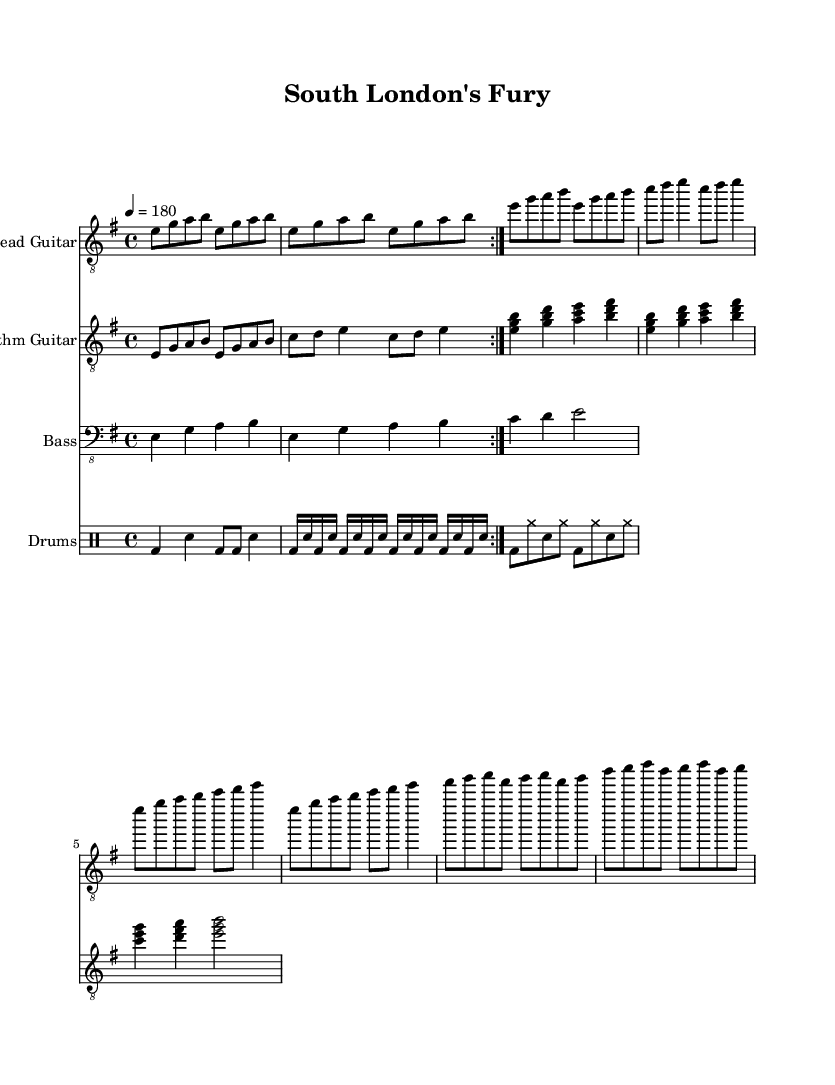What is the key signature of this music? The key signature is E minor, which has one sharp (F#). This is indicated by the presence of an F# note in the music, confirming that the piece is in the E minor scale.
Answer: E minor What is the time signature of this music? The time signature is 4/4, which is noted at the beginning of the score. This means there are four beats in each measure and a quarter note receives one beat.
Answer: 4/4 What is the tempo of this music? The tempo is marked at 180 beats per minute, indicated at the beginning of the score. This intense tempo is typical for thrash metal, allowing for rapid playing.
Answer: 180 How many measures are in the chorus section? The chorus section consists of 8 measures, as seen in the repetitions and how the music is structured, separated from the verses prior to it.
Answer: 8 What style of drumming is used in the verse? The verse features blast beats, a typical characteristic in metal music to create a high-energy atmosphere. This is indicated by the rapid sequence of notes in the drum part.
Answer: Blast beats Which instruments are displayed in this sheet music? The sheet music includes lead guitar, rhythm guitar, bass, and drums, as shown by the corresponding staves for each instrument.
Answer: Lead guitar, rhythm guitar, bass, drums What type of chord progression is used in the rhythm guitar? The rhythm guitar features power chords, demonstrated by stacked notes (root, third, and fifth) which are common in metal music for a heavy sound.
Answer: Power chords 